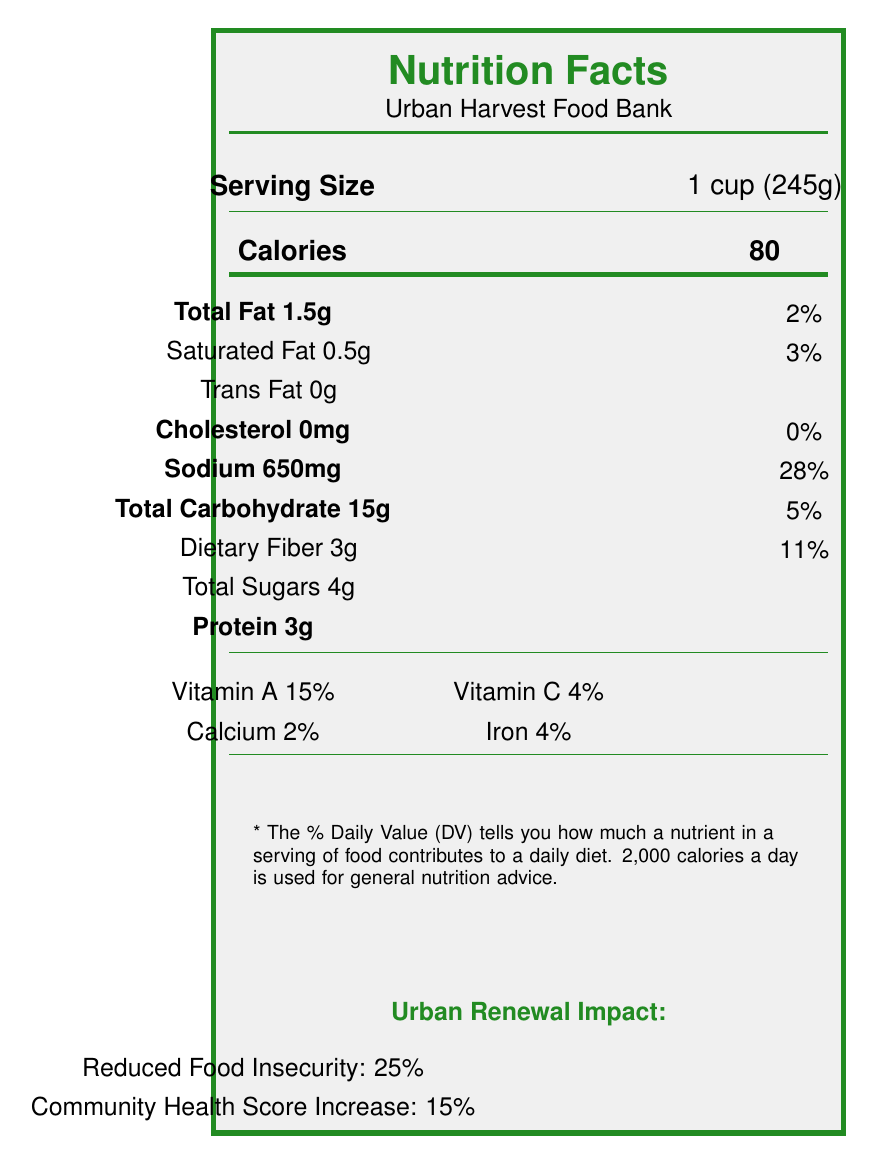What is the sodium content in a serving of Canned Vegetable Soup? The Sodium content is explicitly listed as 650mg under "Sodium" for Canned Vegetable Soup in the nutrition breakdown.
Answer: 650mg How many families are served weekly by the Urban Harvest Food Bank? The document states that 800 families are served weekly by the Urban Harvest Food Bank.
Answer: 800 What is the percentage of iron in a serving of Whole Grain Pasta? The percentage of iron in Whole Grain Pasta is listed as 8% in the nutrition facts.
Answer: 8% How much protein does a serving of Canned Tuna in Water provide? The protein content for Canned Tuna in Water is listed as 13g per serving.
Answer: 13g Which food item has the highest amount of dietary fiber per serving? Canned Black Beans have the highest amount of dietary fiber, with 8g per serving.
Answer: Canned Black Beans What is the main purpose of the Urban Renewal Impact section? A. Describe food items B. Report nutritional education programs C. Highlight improvements in community metrics The Urban Renewal Impact section highlights improvements in community metrics such as reduced food insecurity and increased community health scores.
Answer: C Which food item contains the highest number of calories per serving? A. Canned Vegetable Soup B. Whole Grain Pasta C. Peanut Butter Peanut Butter contains the highest number of calories per serving, with 190 calories.
Answer: C Does the food distribution include work from volunteers? The document mentions 150 volunteers who are involved in the food distribution.
Answer: Yes What are some of the topics covered in the "Healthy Cooking on a Budget" program? The topics listed under the program "Healthy Cooking on a Budget" are meal planning, smart shopping, nutritious recipes, and food safety.
Answer: Meal planning, Smart shopping, Nutritious recipes, Food safety How much has food insecurity been reduced according to the Urban Renewal Impact? The Urban Renewal Impact section states a 25% reduction in food insecurity.
Answer: 25% Please summarize the entire document. The document comprehensively covers the nutritional breakdown of various food items, the impact of urban renewal efforts, and details on educational programs and policy considerations.
Answer: The document provides an overview of nutritional information for food items distributed at the Urban Harvest Food Bank, located at 123 Main Street, Cityville. It includes details on various food items such as Canned Vegetable Soup, Whole Grain Pasta, Canned Tuna, Peanut Butter, and Canned Black Beans. The food bank serves 800 families weekly with the help of 150 volunteers. The Urban Renewal Impact has led to a reduction in food insecurity by 25% and an increase in community health scores by 15%. The document also discusses nutritional education programs like "Healthy Cooking on a Budget" and "Understanding Nutrition Labels," and outlines several policy considerations for improving food access and quality. How many participants attended the "Understanding Nutrition Labels" program? The number of participants for the "Understanding Nutrition Labels" program is listed as 75 in the document.
Answer: 75 What kind of fat does Peanut Butter contain the most? The document lists 16g of total fat for Peanut Butter, which is the highest type of fat compared to its 3g of saturated fat and 0g of trans fat.
Answer: Total fat How many weeks does the "Healthy Cooking on a Budget" program last? The duration of the "Healthy Cooking on a Budget" program is mentioned as 4 weeks.
Answer: 4 weeks What is the calcium percentage in Canned Black Beans? The document specifies that Canned Black Beans contain 4% of the Daily Value of calcium.
Answer: 4% How many food items are distributed at the Urban Harvest Food Bank? The document provides nutrition facts for five food items, but it does not state if these are the only items distributed.
Answer: Cannot be determined 